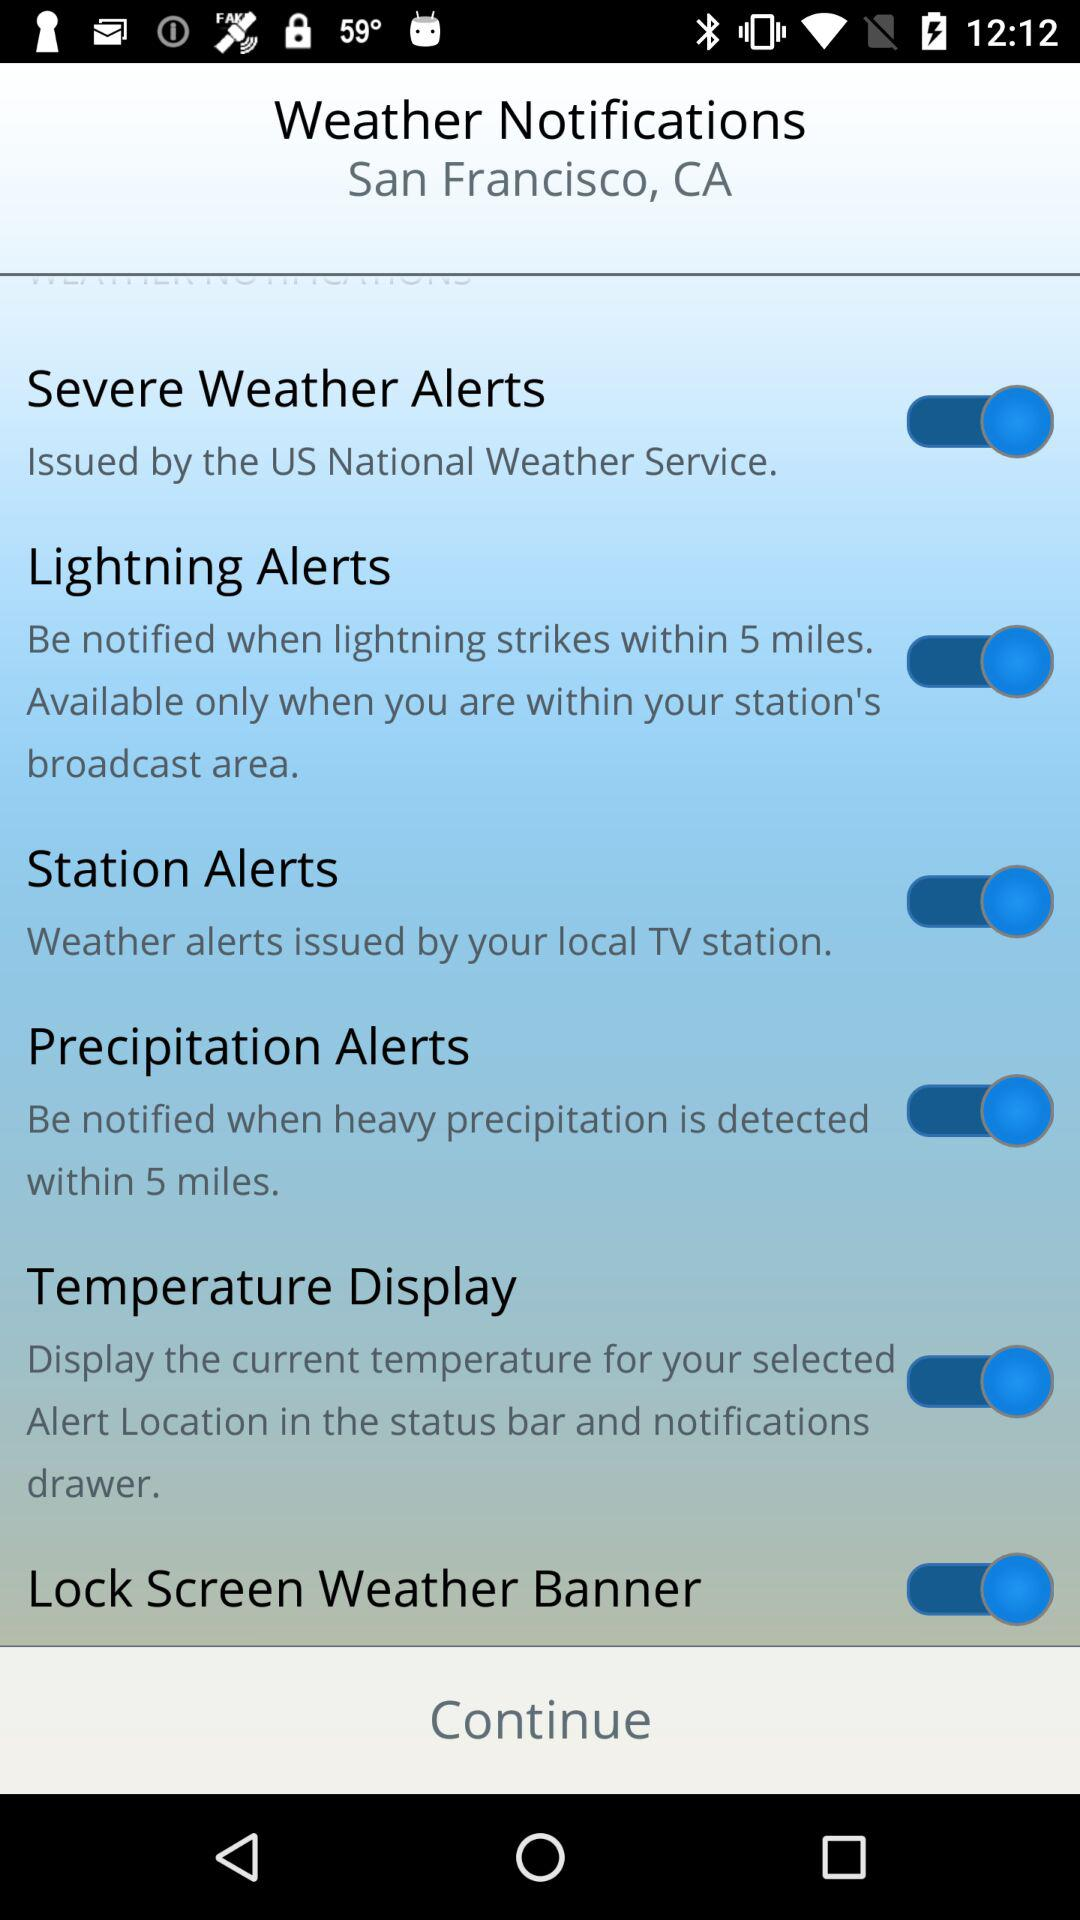What is the status of "Lightning Alerts"? The status is "on". 